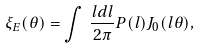Convert formula to latex. <formula><loc_0><loc_0><loc_500><loc_500>\xi _ { E } ( \theta ) = \int \, \frac { l d l } { 2 \pi } P ( l ) J _ { 0 } ( l \theta ) ,</formula> 